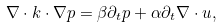Convert formula to latex. <formula><loc_0><loc_0><loc_500><loc_500>\nabla \cdot { k } \cdot \nabla p = \beta \partial _ { t } p + \alpha \partial _ { t } \nabla \cdot { u } ,</formula> 